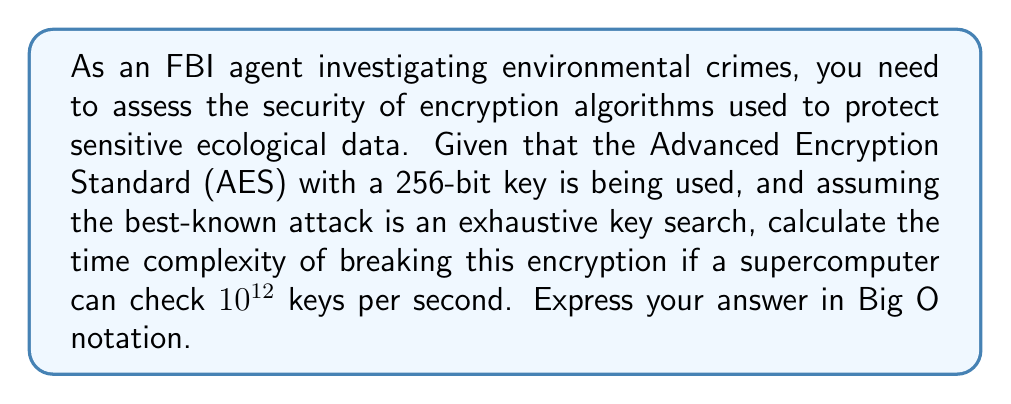Solve this math problem. 1. AES-256 uses a 256-bit key, so the total number of possible keys is $2^{256}$.

2. The time complexity for an exhaustive key search is proportional to the number of possible keys. In this case, it's $O(2^{256})$.

3. To calculate the actual time:
   - Number of keys to check: $2^{256}$
   - Keys checked per second: $10^{12}$
   - Time required: $\frac{2^{256}}{10^{12}}$ seconds

4. Converting to years:
   $$\frac{2^{256}}{10^{12} \cdot 60 \cdot 60 \cdot 24 \cdot 365.25} \approx 1.8 \times 10^{63} \text{ years}$$

5. This astronomical time demonstrates the practical infeasibility of breaking AES-256 through brute force, ensuring the security of environmental data.

6. The time complexity remains $O(2^{256})$, as the constant factor (supercomputer speed) doesn't affect the Big O notation.
Answer: $O(2^{256})$ 